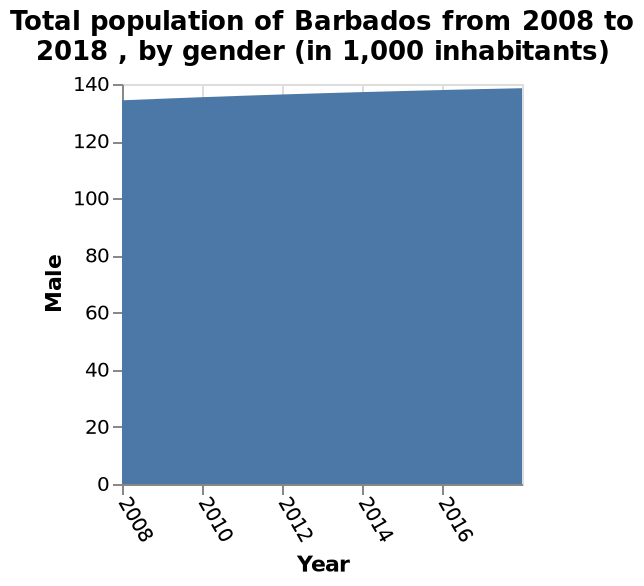<image>
When did the increase in the male population start?  The increase in the male population started in 2008. Offer a thorough analysis of the image. The male population has increased at a fairly constant rate since 2008. 